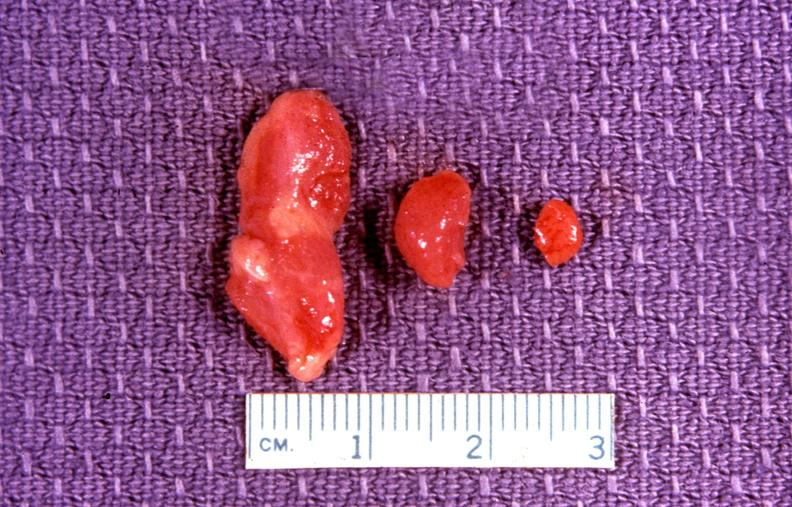does this image show parathyroid, adenoma?
Answer the question using a single word or phrase. Yes 